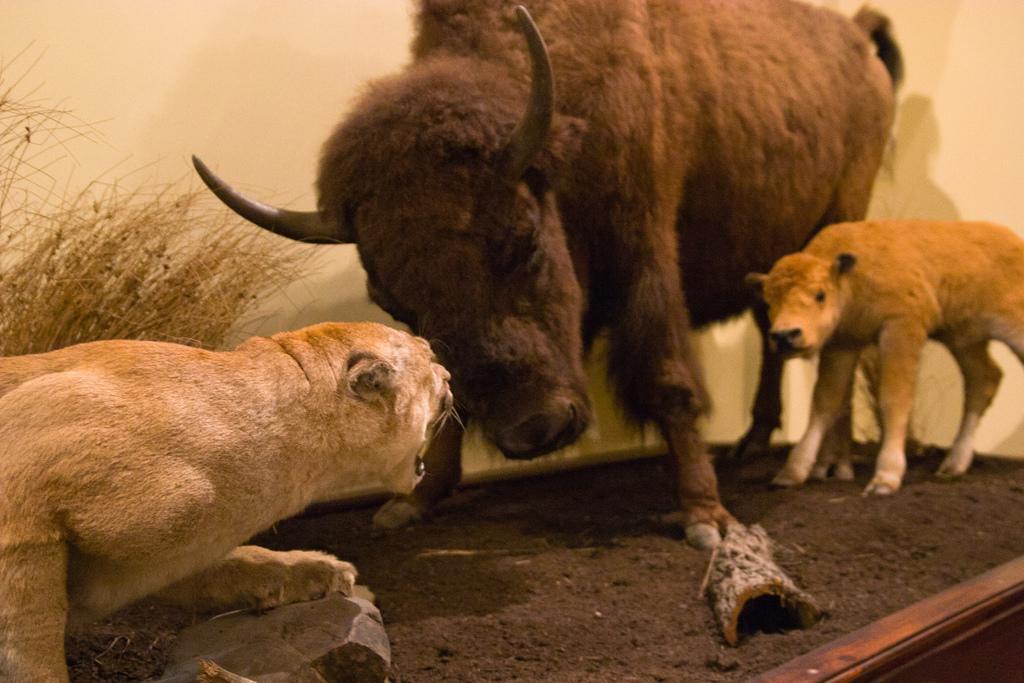How would you summarize this image in a sentence or two? In this image there is a roaring tiger on the left side. On the right side there is a cow. In the middle there is a bull. In the background there is a wall. At the bottom there is sand. 